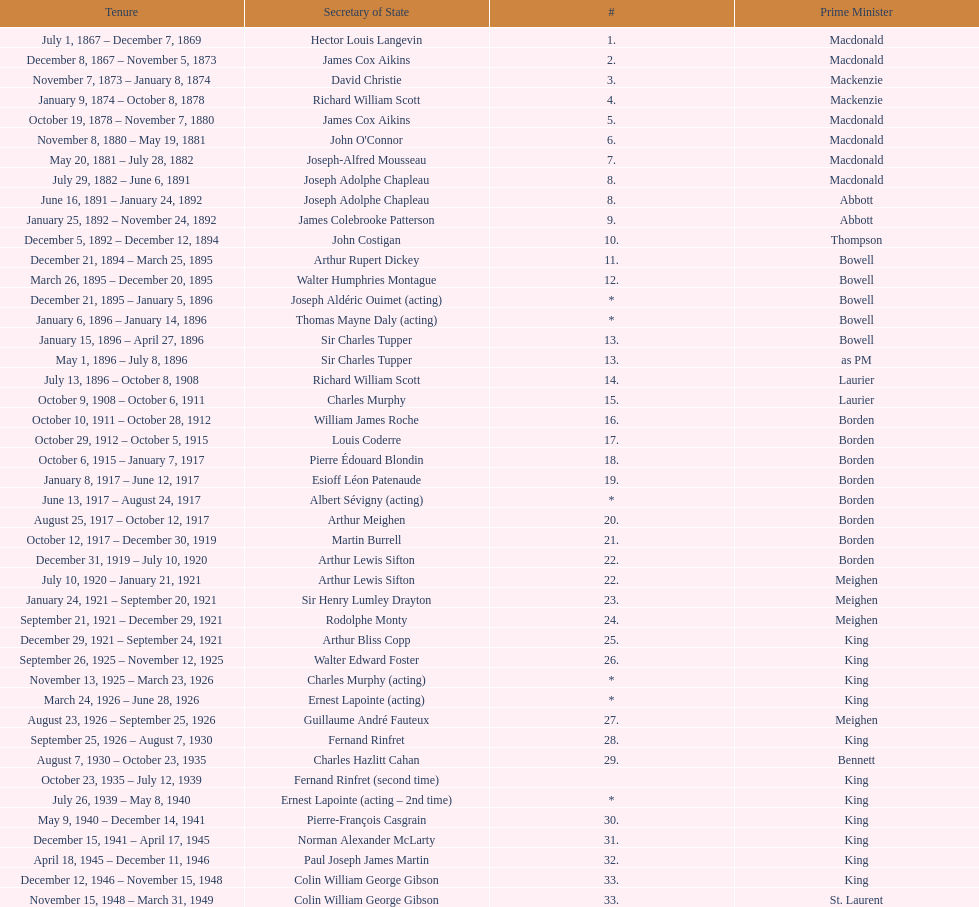Who was thompson's secretary of state? John Costigan. 